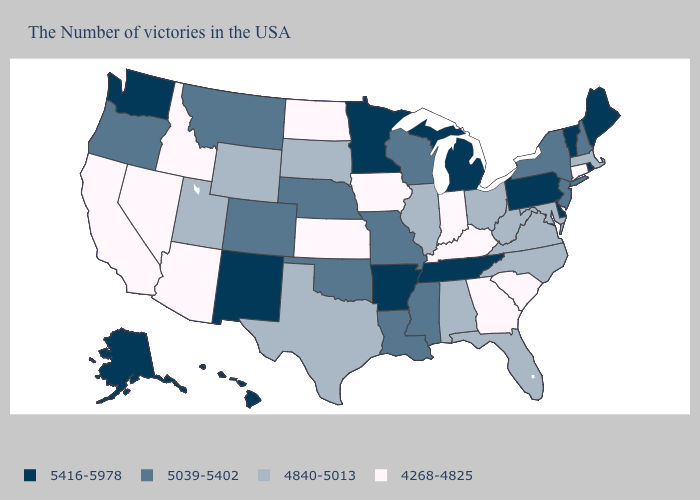What is the lowest value in the South?
Concise answer only. 4268-4825. Does Michigan have the highest value in the MidWest?
Short answer required. Yes. Which states have the lowest value in the USA?
Concise answer only. Connecticut, South Carolina, Georgia, Kentucky, Indiana, Iowa, Kansas, North Dakota, Arizona, Idaho, Nevada, California. Name the states that have a value in the range 4840-5013?
Concise answer only. Massachusetts, Maryland, Virginia, North Carolina, West Virginia, Ohio, Florida, Alabama, Illinois, Texas, South Dakota, Wyoming, Utah. Which states hav the highest value in the Northeast?
Keep it brief. Maine, Rhode Island, Vermont, Pennsylvania. Name the states that have a value in the range 5416-5978?
Short answer required. Maine, Rhode Island, Vermont, Delaware, Pennsylvania, Michigan, Tennessee, Arkansas, Minnesota, New Mexico, Washington, Alaska, Hawaii. Is the legend a continuous bar?
Be succinct. No. Which states hav the highest value in the MidWest?
Keep it brief. Michigan, Minnesota. Name the states that have a value in the range 4268-4825?
Answer briefly. Connecticut, South Carolina, Georgia, Kentucky, Indiana, Iowa, Kansas, North Dakota, Arizona, Idaho, Nevada, California. What is the lowest value in states that border Utah?
Write a very short answer. 4268-4825. Which states have the highest value in the USA?
Concise answer only. Maine, Rhode Island, Vermont, Delaware, Pennsylvania, Michigan, Tennessee, Arkansas, Minnesota, New Mexico, Washington, Alaska, Hawaii. Name the states that have a value in the range 4840-5013?
Give a very brief answer. Massachusetts, Maryland, Virginia, North Carolina, West Virginia, Ohio, Florida, Alabama, Illinois, Texas, South Dakota, Wyoming, Utah. Does New Mexico have a lower value than Florida?
Give a very brief answer. No. Name the states that have a value in the range 4268-4825?
Keep it brief. Connecticut, South Carolina, Georgia, Kentucky, Indiana, Iowa, Kansas, North Dakota, Arizona, Idaho, Nevada, California. 